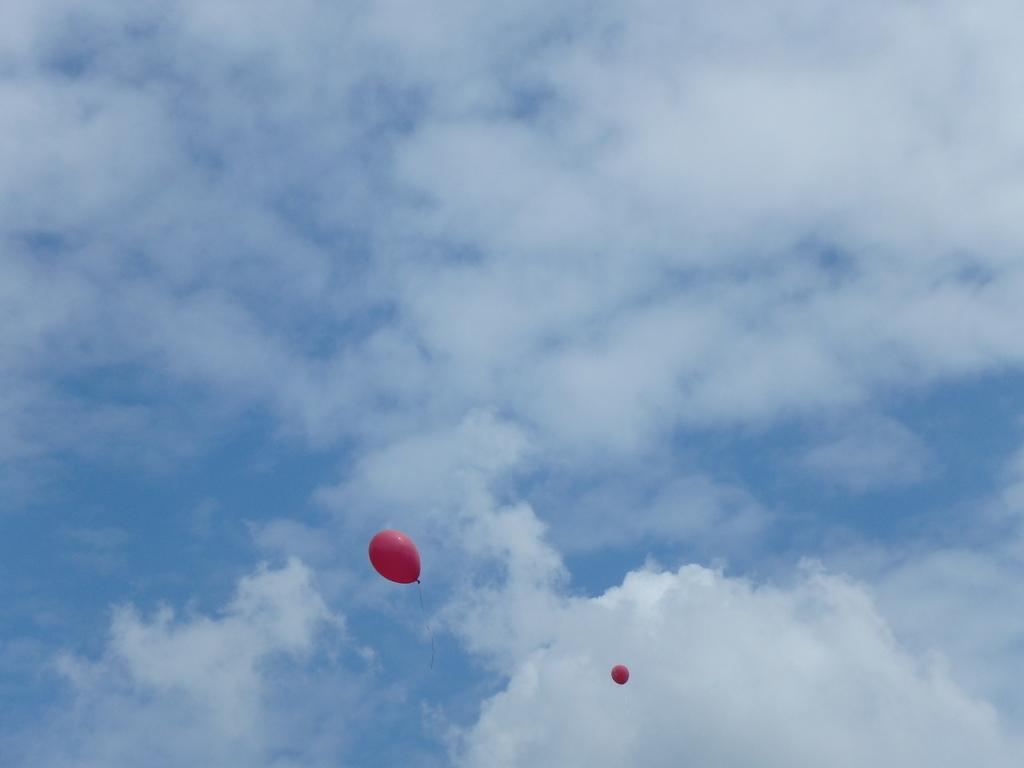What objects can be seen in the sky in the image? There are two balloons in the sky in the image. How would you describe the sky in the image? The sky appears to be cloudy in the image. What type of transport can be seen in the image? There is no transport visible in the image; it only features two balloons in the sky. Is there a picture of a famous landmark in the image? There is no picture of a famous landmark present in the image. 